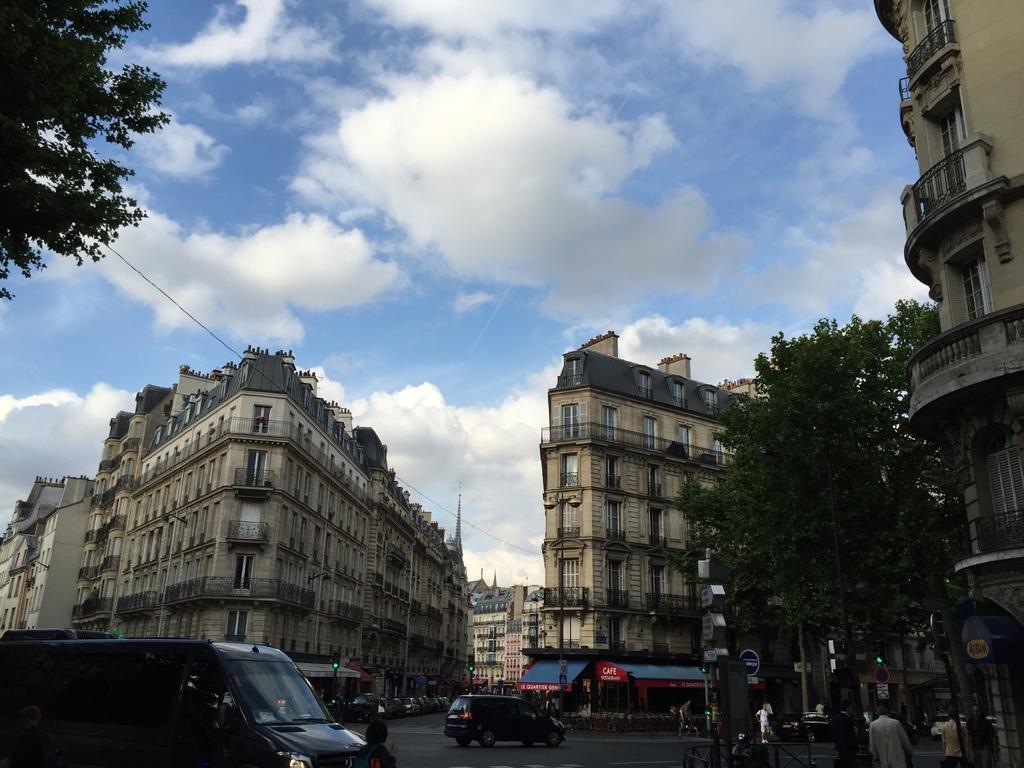Could you give a brief overview of what you see in this image? This is an outside view. At the bottom I can see few vehicles on the road and also there are many people. Beside the road there are few light poles. In the background there are many buildings. on the right and left side of the image there are few trees. At the top of the image I can see the sky and clouds. 